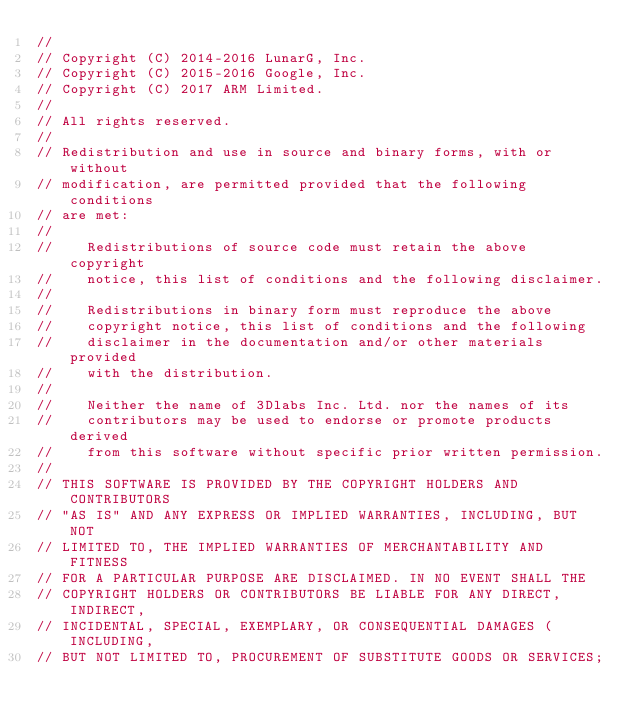<code> <loc_0><loc_0><loc_500><loc_500><_C++_>//
// Copyright (C) 2014-2016 LunarG, Inc.
// Copyright (C) 2015-2016 Google, Inc.
// Copyright (C) 2017 ARM Limited.
//
// All rights reserved.
//
// Redistribution and use in source and binary forms, with or without
// modification, are permitted provided that the following conditions
// are met:
//
//    Redistributions of source code must retain the above copyright
//    notice, this list of conditions and the following disclaimer.
//
//    Redistributions in binary form must reproduce the above
//    copyright notice, this list of conditions and the following
//    disclaimer in the documentation and/or other materials provided
//    with the distribution.
//
//    Neither the name of 3Dlabs Inc. Ltd. nor the names of its
//    contributors may be used to endorse or promote products derived
//    from this software without specific prior written permission.
//
// THIS SOFTWARE IS PROVIDED BY THE COPYRIGHT HOLDERS AND CONTRIBUTORS
// "AS IS" AND ANY EXPRESS OR IMPLIED WARRANTIES, INCLUDING, BUT NOT
// LIMITED TO, THE IMPLIED WARRANTIES OF MERCHANTABILITY AND FITNESS
// FOR A PARTICULAR PURPOSE ARE DISCLAIMED. IN NO EVENT SHALL THE
// COPYRIGHT HOLDERS OR CONTRIBUTORS BE LIABLE FOR ANY DIRECT, INDIRECT,
// INCIDENTAL, SPECIAL, EXEMPLARY, OR CONSEQUENTIAL DAMAGES (INCLUDING,
// BUT NOT LIMITED TO, PROCUREMENT OF SUBSTITUTE GOODS OR SERVICES;</code> 